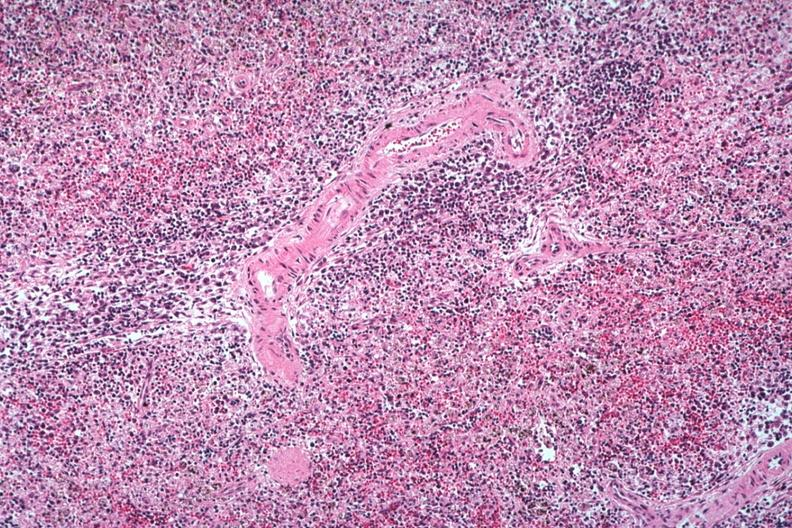what is present?
Answer the question using a single word or phrase. Spleen 